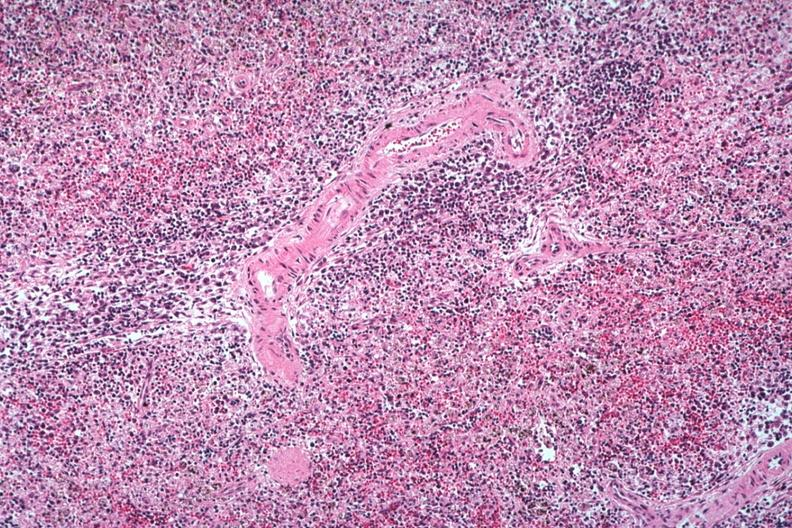what is present?
Answer the question using a single word or phrase. Spleen 